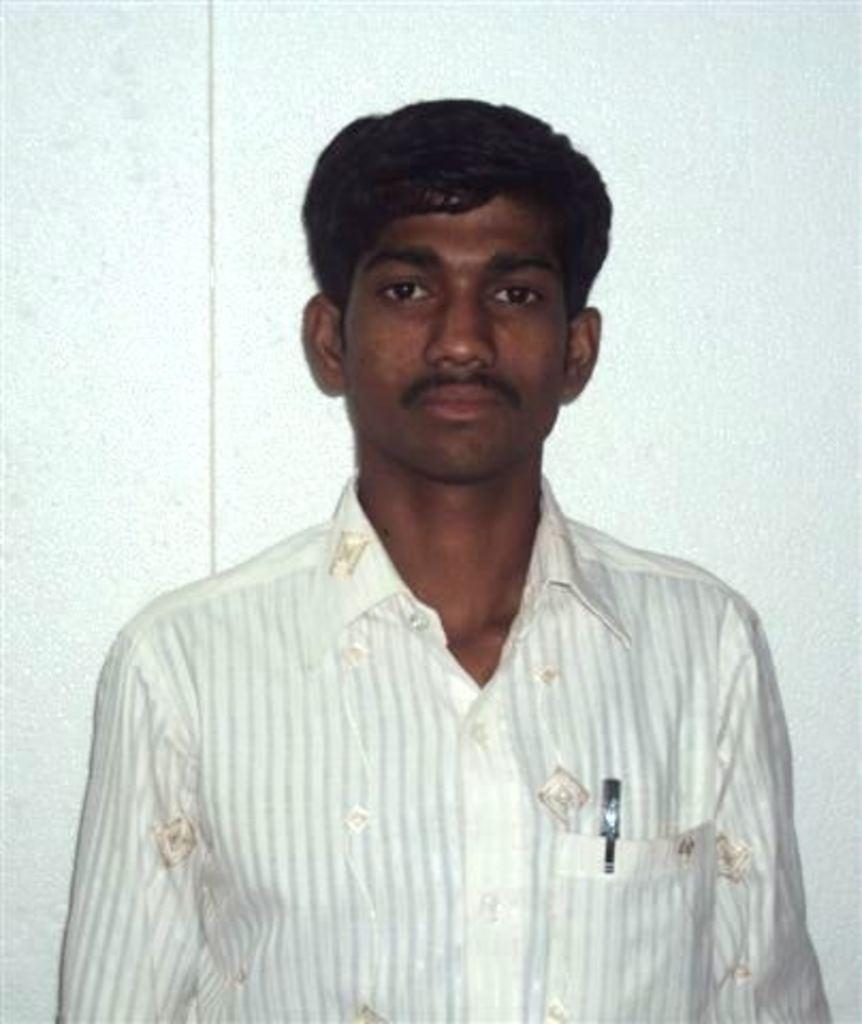Could you give a brief overview of what you see in this image? In this image I can see the person wearing the white and cream color dress and I can see the pen in the pocket. And there is a white background. 